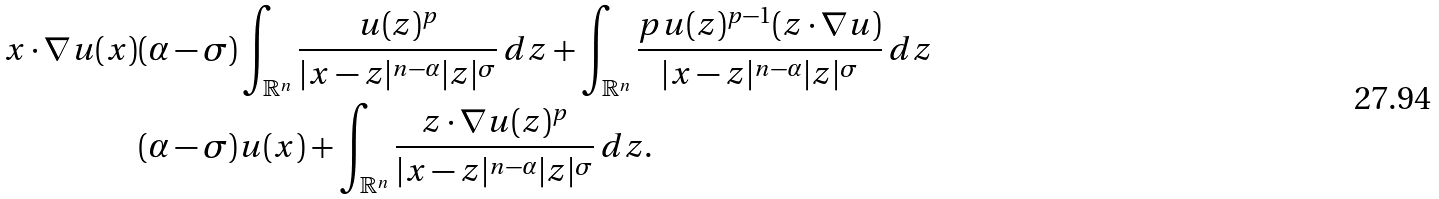<formula> <loc_0><loc_0><loc_500><loc_500>x \cdot \nabla u ( x ) & ( \alpha - \sigma ) \int _ { \mathbb { R } ^ { n } } \frac { u ( z ) ^ { p } } { | x - z | ^ { n - \alpha } | z | ^ { \sigma } } \, d z + \int _ { \mathbb { R } ^ { n } } \frac { p u ( z ) ^ { p - 1 } ( z \cdot \nabla u ) } { | x - z | ^ { n - \alpha } | z | ^ { \sigma } } \, d z \\ & ( \alpha - \sigma ) u ( x ) + \int _ { \mathbb { R } ^ { n } } \frac { z \cdot \nabla u ( z ) ^ { p } } { | x - z | ^ { n - \alpha } | z | ^ { \sigma } } \, d z .</formula> 